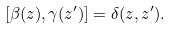<formula> <loc_0><loc_0><loc_500><loc_500>[ \beta ( z ) , \gamma ( z ^ { \prime } ) ] = \delta ( z , z ^ { \prime } ) .</formula> 